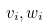<formula> <loc_0><loc_0><loc_500><loc_500>v _ { i } , w _ { i }</formula> 